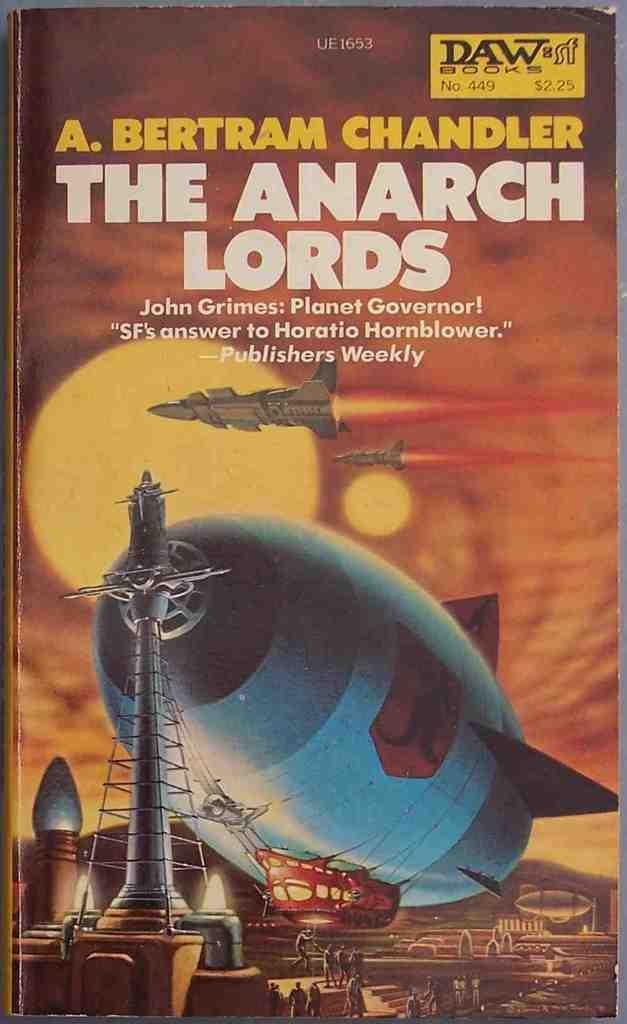Provide a one-sentence caption for the provided image. A paperback book called The Anarch Lords which has a picture of a zephyr and spaceships in front of 2 suns. 